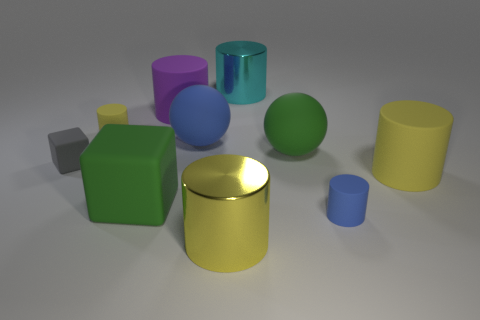Can you tell which object appears to be the smallest and what its color is? The smallest object in the image appears to be the tiny blue cube situated to the far right. Its deep blue shade contrasts with the lighter blue of the larger cylinder nearby, and its size is dwarfed by all other objects in the scene. 